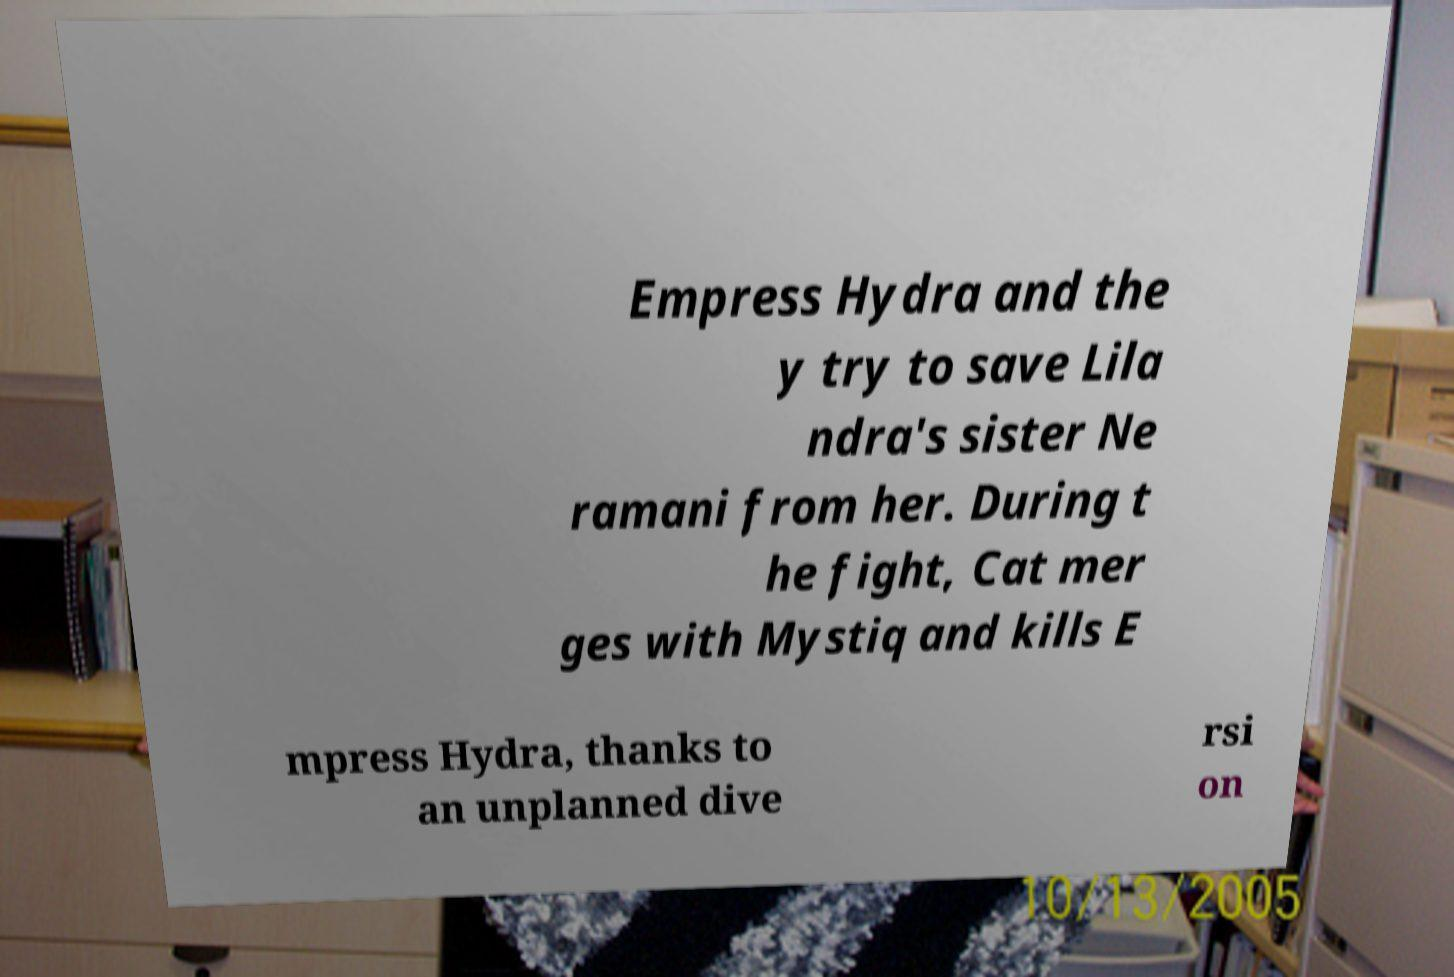Could you extract and type out the text from this image? Empress Hydra and the y try to save Lila ndra's sister Ne ramani from her. During t he fight, Cat mer ges with Mystiq and kills E mpress Hydra, thanks to an unplanned dive rsi on 